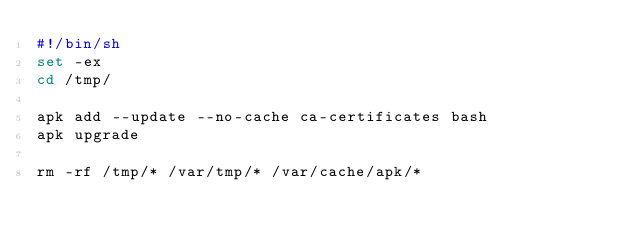Convert code to text. <code><loc_0><loc_0><loc_500><loc_500><_Bash_>#!/bin/sh
set -ex
cd /tmp/

apk add --update --no-cache ca-certificates bash
apk upgrade

rm -rf /tmp/* /var/tmp/* /var/cache/apk/*</code> 